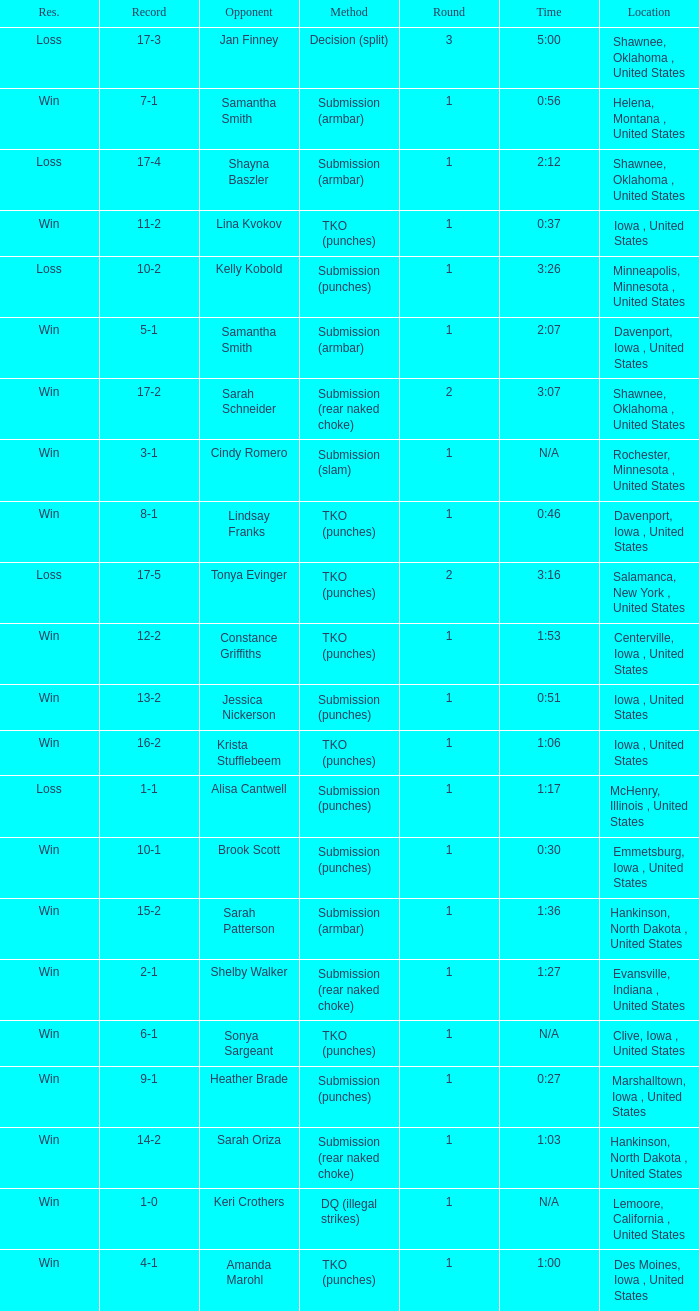What is the highest number of rounds for a 3:16 fight? 2.0. 